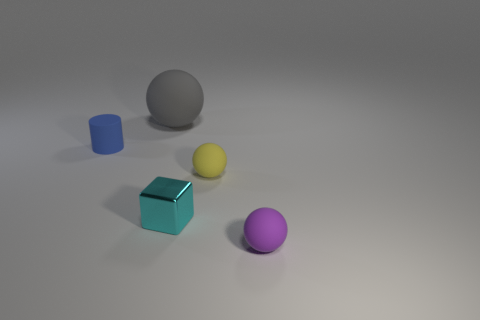Is there any other thing that is the same material as the small cyan cube?
Ensure brevity in your answer.  No. There is a small yellow object that is the same shape as the big rubber thing; what is its material?
Offer a terse response. Rubber. Are there any metal objects?
Offer a terse response. Yes. There is a purple object that is the same material as the yellow sphere; what shape is it?
Offer a very short reply. Sphere. There is a ball that is in front of the cyan metallic object; what is its material?
Offer a terse response. Rubber. There is a small thing to the left of the gray ball; is its color the same as the large sphere?
Offer a terse response. No. What is the size of the rubber thing that is behind the rubber object that is on the left side of the large gray sphere?
Your response must be concise. Large. Is the number of cyan metallic things that are on the right side of the small cyan shiny object greater than the number of tiny gray shiny spheres?
Give a very brief answer. No. There is a rubber ball that is behind the cylinder; does it have the same size as the tiny blue matte thing?
Your answer should be compact. No. What color is the matte thing that is in front of the gray thing and behind the yellow sphere?
Provide a short and direct response. Blue. 